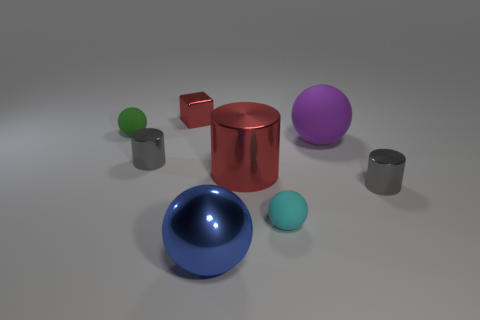Is there any other thing that is the same shape as the small red shiny object?
Make the answer very short. No. What number of cylinders have the same color as the block?
Ensure brevity in your answer.  1. What is the size of the metal cylinder that is the same color as the block?
Offer a terse response. Large. How many big things are behind the tiny cylinder on the right side of the red thing behind the green matte sphere?
Give a very brief answer. 2. How many cyan things are there?
Provide a succinct answer. 1. Is the number of blue objects behind the red shiny block less than the number of gray shiny cylinders on the right side of the large red cylinder?
Give a very brief answer. Yes. Is the number of cyan matte objects behind the cyan rubber ball less than the number of large green shiny cylinders?
Provide a short and direct response. No. The big sphere that is to the right of the big thing in front of the cylinder that is on the right side of the large red cylinder is made of what material?
Your answer should be very brief. Rubber. What number of things are either metallic cylinders to the right of the purple rubber sphere or gray shiny cylinders in front of the large red thing?
Offer a terse response. 1. There is a blue thing that is the same shape as the small green matte thing; what is it made of?
Your response must be concise. Metal. 